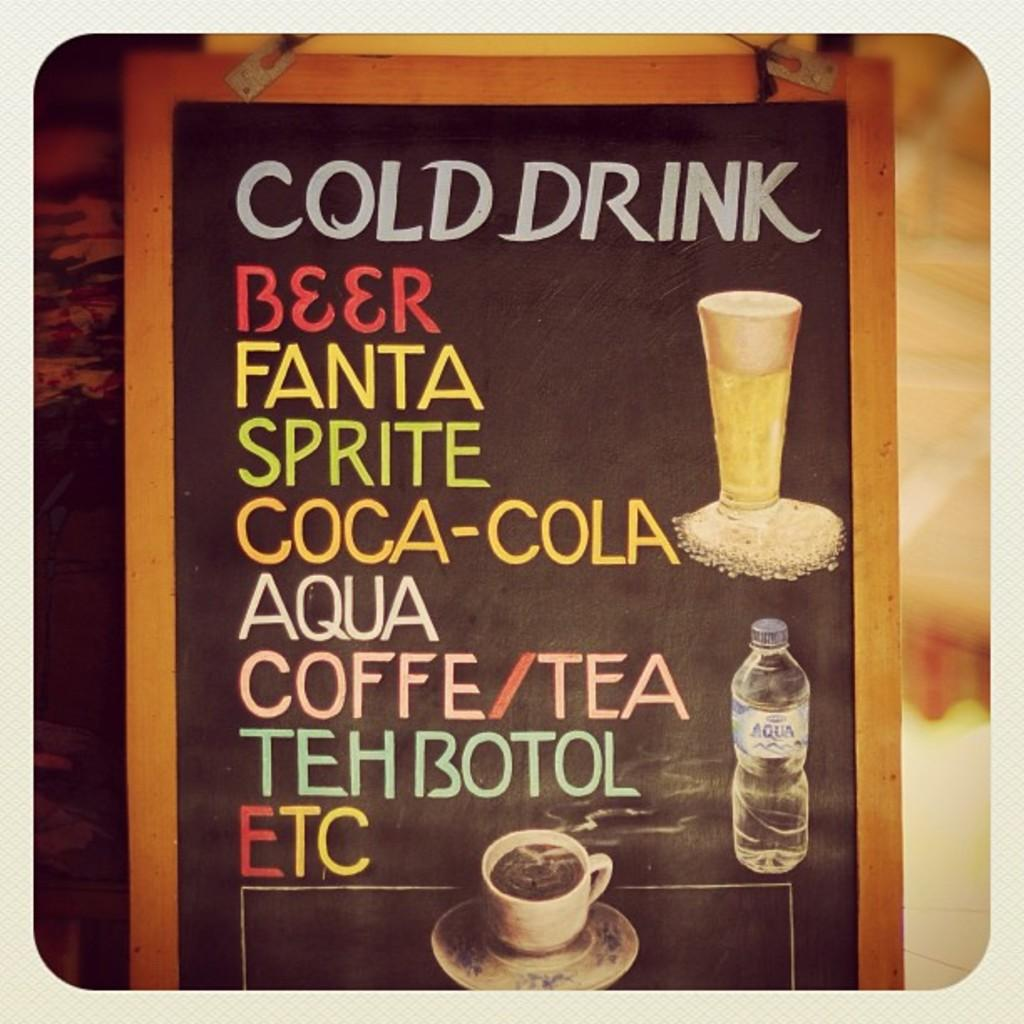What type of image is being described? The image is a photograph. What is the main subject in the center of the image? There is a board in the center of the image. How would you describe the background of the image? The background of the image is blurry. What type of lunch is being served in the image? There is no lunch present in the image; it features a board in the center and a blurry background. What kind of music is being played by the band in the image? There is no band present in the image; it only features a board and a blurry background. 